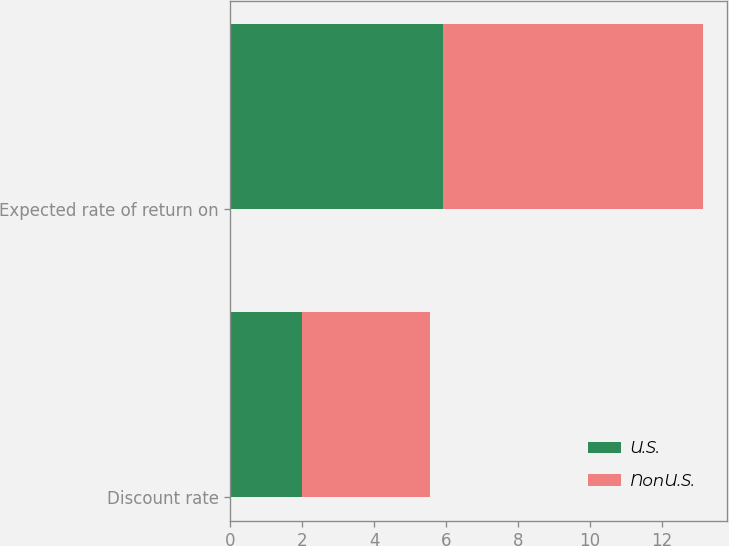Convert chart. <chart><loc_0><loc_0><loc_500><loc_500><stacked_bar_chart><ecel><fcel>Discount rate<fcel>Expected rate of return on<nl><fcel>U.S.<fcel>1.99<fcel>5.9<nl><fcel>NonU.S.<fcel>3.56<fcel>7.25<nl></chart> 